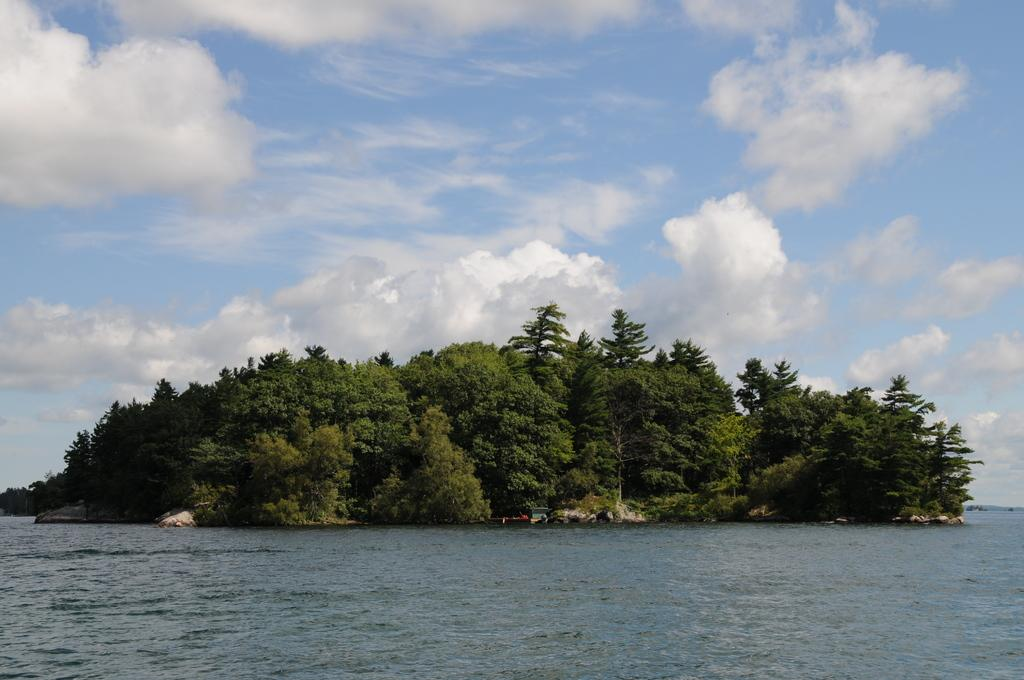What is at the bottom of the image? There is water at the bottom of the image. What can be seen in the middle of the image? There are many trees in the middle of the water. What is visible at the top of the image? The sky is visible at the top of the image. What can be observed in the sky? Clouds are present in the sky. What type of plant is growing inside the mind of the person in the image? There is no person or mind present in the image; it features water, trees, sky, and clouds. 